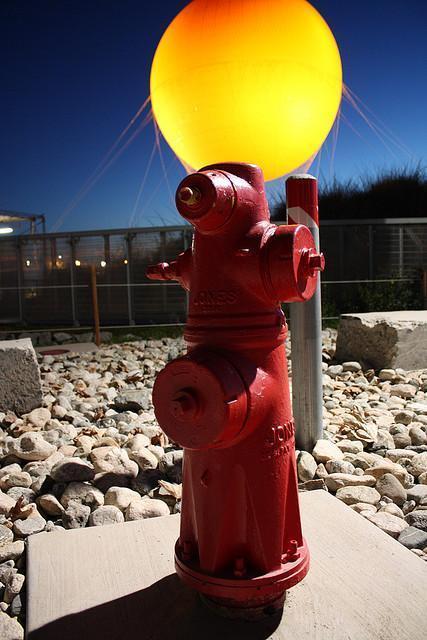How many rolls of toilet paper are on top of the toilet?
Give a very brief answer. 0. 